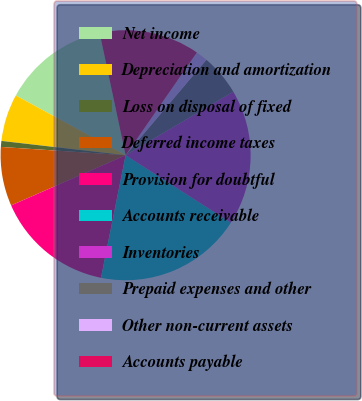Convert chart. <chart><loc_0><loc_0><loc_500><loc_500><pie_chart><fcel>Net income<fcel>Depreciation and amortization<fcel>Loss on disposal of fixed<fcel>Deferred income taxes<fcel>Provision for doubtful<fcel>Accounts receivable<fcel>Inventories<fcel>Prepaid expenses and other<fcel>Other non-current assets<fcel>Accounts payable<nl><fcel>13.74%<fcel>6.11%<fcel>0.77%<fcel>7.63%<fcel>15.27%<fcel>19.08%<fcel>17.56%<fcel>5.34%<fcel>1.53%<fcel>12.98%<nl></chart> 